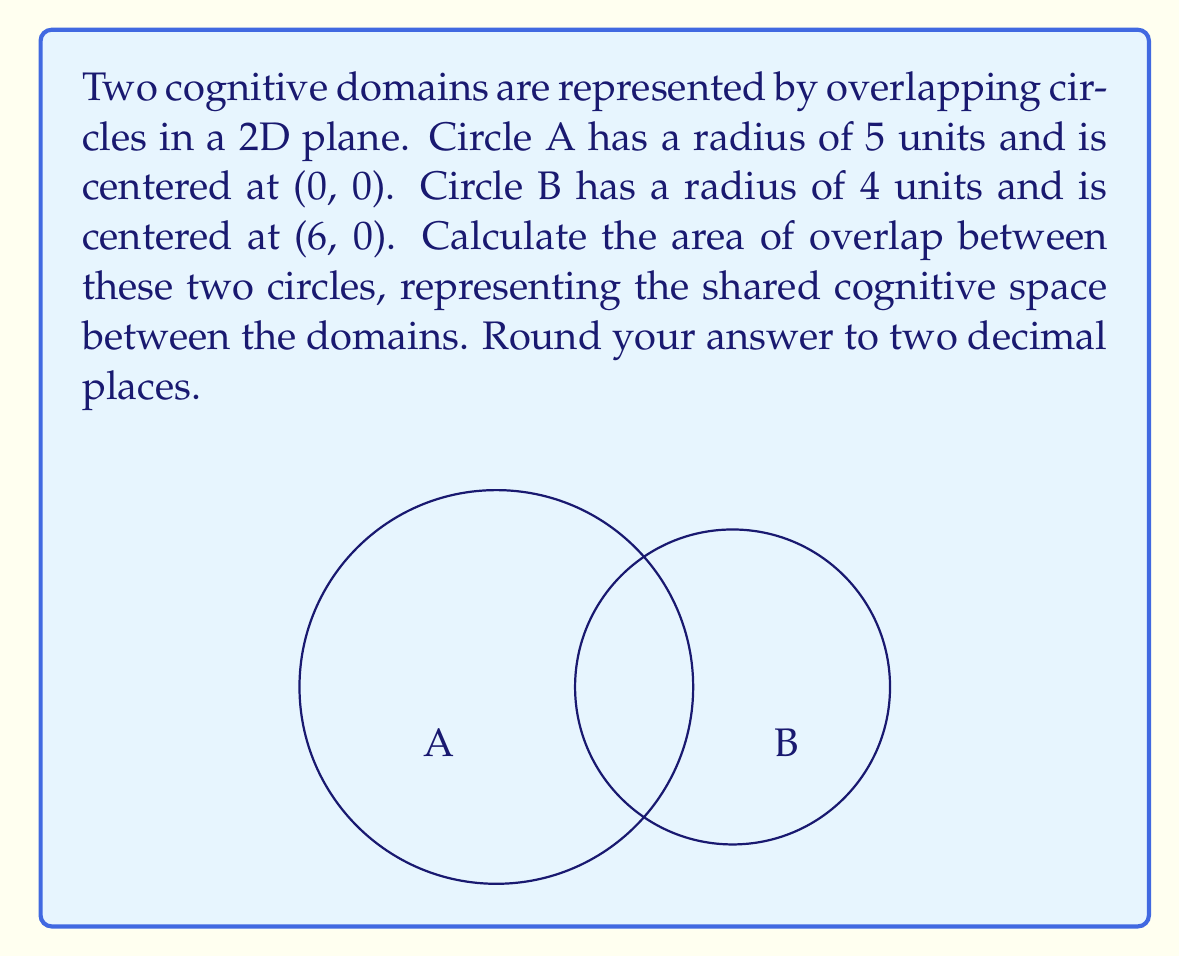What is the answer to this math problem? To solve this problem, we'll follow these steps:

1) First, we need to find the distance between the centers of the circles:
   $d = 6$ (given in the question)

2) Next, we'll calculate the radii:
   $r_1 = 5$ (Circle A)
   $r_2 = 4$ (Circle B)

3) To find the area of overlap, we'll use the formula for the area of intersection of two circles:

   $$A = r_1^2 \arccos(\frac{d^2 + r_1^2 - r_2^2}{2dr_1}) + r_2^2 \arccos(\frac{d^2 + r_2^2 - r_1^2}{2dr_2}) - \frac{1}{2}\sqrt{(-d+r_1+r_2)(d+r_1-r_2)(d-r_1+r_2)(d+r_1+r_2)}$$

4) Let's substitute our values:

   $$A = 5^2 \arccos(\frac{6^2 + 5^2 - 4^2}{2 \cdot 6 \cdot 5}) + 4^2 \arccos(\frac{6^2 + 4^2 - 5^2}{2 \cdot 6 \cdot 4}) - \frac{1}{2}\sqrt{(-6+5+4)(6+5-4)(6-5+4)(6+5+4)}$$

5) Simplify:

   $$A = 25 \arccos(\frac{61}{60}) + 16 \arccos(\frac{11}{48}) - \frac{1}{2}\sqrt{3 \cdot 7 \cdot 5 \cdot 15}$$

6) Calculate:

   $$A \approx 25 \cdot 0.8479 + 16 \cdot 1.3409 - \frac{1}{2} \cdot 18.3303$$

   $$A \approx 21.1975 + 21.4544 - 9.1652$$

   $$A \approx 33.4867$$

7) Rounding to two decimal places:

   $$A \approx 33.49$$
Answer: $33.49$ square units 